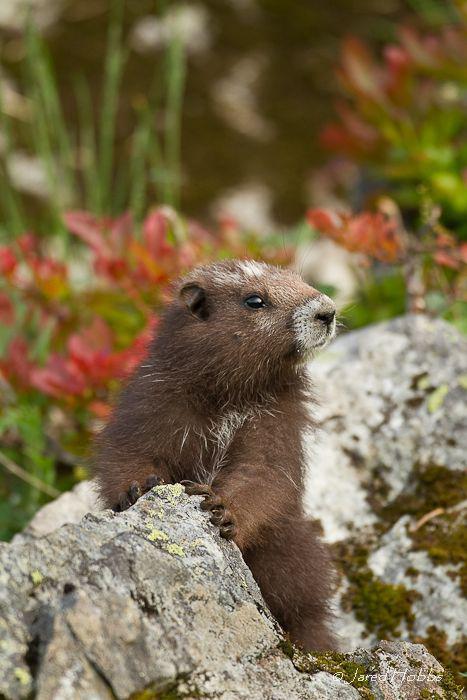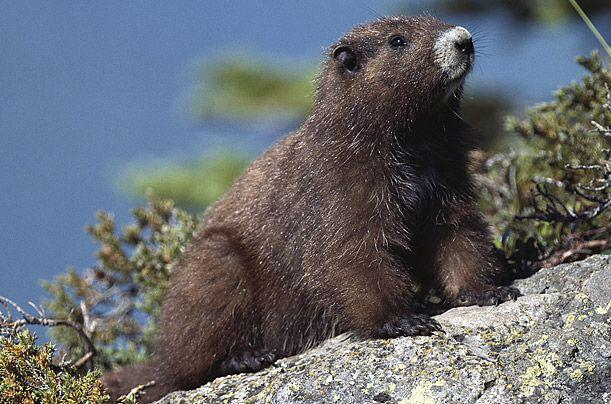The first image is the image on the left, the second image is the image on the right. For the images shown, is this caption "There are exactly three marmots." true? Answer yes or no. No. The first image is the image on the left, the second image is the image on the right. For the images shown, is this caption "We've got three groundhogs here." true? Answer yes or no. No. 